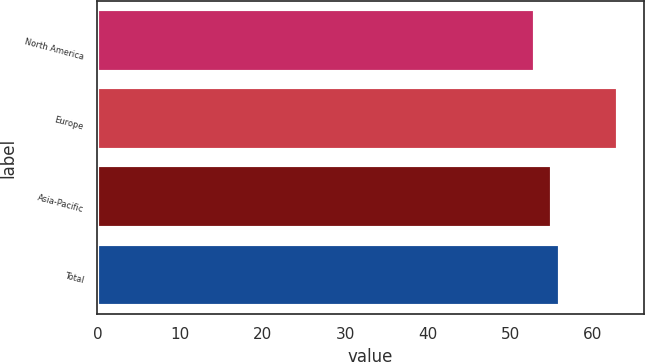<chart> <loc_0><loc_0><loc_500><loc_500><bar_chart><fcel>North America<fcel>Europe<fcel>Asia-Pacific<fcel>Total<nl><fcel>53<fcel>63<fcel>55<fcel>56<nl></chart> 